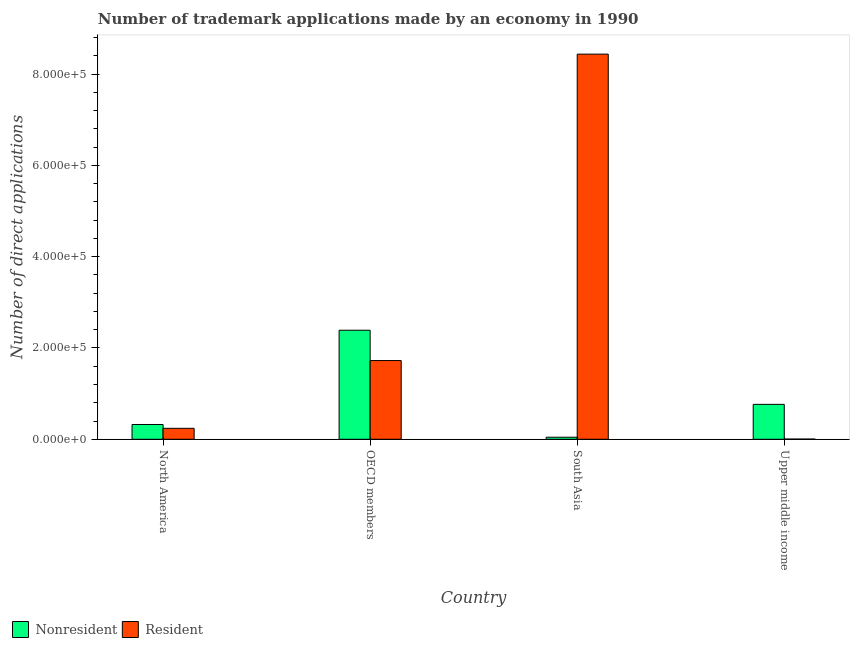How many different coloured bars are there?
Your answer should be compact. 2. How many groups of bars are there?
Your response must be concise. 4. Are the number of bars per tick equal to the number of legend labels?
Keep it short and to the point. Yes. What is the label of the 2nd group of bars from the left?
Offer a very short reply. OECD members. What is the number of trademark applications made by non residents in OECD members?
Offer a terse response. 2.39e+05. Across all countries, what is the maximum number of trademark applications made by non residents?
Provide a short and direct response. 2.39e+05. Across all countries, what is the minimum number of trademark applications made by residents?
Your response must be concise. 461. In which country was the number of trademark applications made by residents maximum?
Provide a succinct answer. South Asia. In which country was the number of trademark applications made by residents minimum?
Offer a very short reply. Upper middle income. What is the total number of trademark applications made by residents in the graph?
Keep it short and to the point. 1.04e+06. What is the difference between the number of trademark applications made by non residents in OECD members and that in Upper middle income?
Offer a terse response. 1.62e+05. What is the difference between the number of trademark applications made by residents in Upper middle income and the number of trademark applications made by non residents in South Asia?
Your answer should be compact. -4037. What is the average number of trademark applications made by non residents per country?
Provide a short and direct response. 8.81e+04. What is the difference between the number of trademark applications made by non residents and number of trademark applications made by residents in South Asia?
Give a very brief answer. -8.39e+05. What is the ratio of the number of trademark applications made by non residents in North America to that in South Asia?
Offer a very short reply. 7.2. What is the difference between the highest and the second highest number of trademark applications made by non residents?
Your response must be concise. 1.62e+05. What is the difference between the highest and the lowest number of trademark applications made by residents?
Offer a terse response. 8.43e+05. Is the sum of the number of trademark applications made by residents in North America and OECD members greater than the maximum number of trademark applications made by non residents across all countries?
Keep it short and to the point. No. What does the 1st bar from the left in Upper middle income represents?
Offer a terse response. Nonresident. What does the 2nd bar from the right in OECD members represents?
Offer a terse response. Nonresident. How many bars are there?
Your answer should be very brief. 8. How many countries are there in the graph?
Offer a terse response. 4. Does the graph contain any zero values?
Ensure brevity in your answer.  No. How are the legend labels stacked?
Provide a short and direct response. Horizontal. What is the title of the graph?
Ensure brevity in your answer.  Number of trademark applications made by an economy in 1990. What is the label or title of the Y-axis?
Your answer should be compact. Number of direct applications. What is the Number of direct applications in Nonresident in North America?
Your response must be concise. 3.24e+04. What is the Number of direct applications of Resident in North America?
Offer a very short reply. 2.40e+04. What is the Number of direct applications in Nonresident in OECD members?
Provide a short and direct response. 2.39e+05. What is the Number of direct applications in Resident in OECD members?
Your answer should be compact. 1.72e+05. What is the Number of direct applications of Nonresident in South Asia?
Give a very brief answer. 4498. What is the Number of direct applications in Resident in South Asia?
Keep it short and to the point. 8.44e+05. What is the Number of direct applications of Nonresident in Upper middle income?
Ensure brevity in your answer.  7.65e+04. What is the Number of direct applications in Resident in Upper middle income?
Offer a terse response. 461. Across all countries, what is the maximum Number of direct applications of Nonresident?
Offer a terse response. 2.39e+05. Across all countries, what is the maximum Number of direct applications in Resident?
Make the answer very short. 8.44e+05. Across all countries, what is the minimum Number of direct applications in Nonresident?
Your response must be concise. 4498. Across all countries, what is the minimum Number of direct applications in Resident?
Your answer should be compact. 461. What is the total Number of direct applications in Nonresident in the graph?
Make the answer very short. 3.52e+05. What is the total Number of direct applications in Resident in the graph?
Provide a short and direct response. 1.04e+06. What is the difference between the Number of direct applications in Nonresident in North America and that in OECD members?
Offer a terse response. -2.06e+05. What is the difference between the Number of direct applications in Resident in North America and that in OECD members?
Keep it short and to the point. -1.48e+05. What is the difference between the Number of direct applications in Nonresident in North America and that in South Asia?
Provide a succinct answer. 2.79e+04. What is the difference between the Number of direct applications of Resident in North America and that in South Asia?
Provide a succinct answer. -8.20e+05. What is the difference between the Number of direct applications of Nonresident in North America and that in Upper middle income?
Keep it short and to the point. -4.41e+04. What is the difference between the Number of direct applications in Resident in North America and that in Upper middle income?
Your answer should be very brief. 2.35e+04. What is the difference between the Number of direct applications in Nonresident in OECD members and that in South Asia?
Keep it short and to the point. 2.34e+05. What is the difference between the Number of direct applications of Resident in OECD members and that in South Asia?
Provide a succinct answer. -6.71e+05. What is the difference between the Number of direct applications in Nonresident in OECD members and that in Upper middle income?
Ensure brevity in your answer.  1.62e+05. What is the difference between the Number of direct applications of Resident in OECD members and that in Upper middle income?
Provide a short and direct response. 1.72e+05. What is the difference between the Number of direct applications of Nonresident in South Asia and that in Upper middle income?
Ensure brevity in your answer.  -7.20e+04. What is the difference between the Number of direct applications of Resident in South Asia and that in Upper middle income?
Ensure brevity in your answer.  8.43e+05. What is the difference between the Number of direct applications in Nonresident in North America and the Number of direct applications in Resident in OECD members?
Offer a terse response. -1.40e+05. What is the difference between the Number of direct applications in Nonresident in North America and the Number of direct applications in Resident in South Asia?
Offer a very short reply. -8.11e+05. What is the difference between the Number of direct applications in Nonresident in North America and the Number of direct applications in Resident in Upper middle income?
Provide a short and direct response. 3.19e+04. What is the difference between the Number of direct applications in Nonresident in OECD members and the Number of direct applications in Resident in South Asia?
Provide a short and direct response. -6.05e+05. What is the difference between the Number of direct applications of Nonresident in OECD members and the Number of direct applications of Resident in Upper middle income?
Make the answer very short. 2.38e+05. What is the difference between the Number of direct applications of Nonresident in South Asia and the Number of direct applications of Resident in Upper middle income?
Your answer should be compact. 4037. What is the average Number of direct applications in Nonresident per country?
Your answer should be compact. 8.81e+04. What is the average Number of direct applications in Resident per country?
Keep it short and to the point. 2.60e+05. What is the difference between the Number of direct applications of Nonresident and Number of direct applications of Resident in North America?
Provide a succinct answer. 8403. What is the difference between the Number of direct applications in Nonresident and Number of direct applications in Resident in OECD members?
Keep it short and to the point. 6.64e+04. What is the difference between the Number of direct applications in Nonresident and Number of direct applications in Resident in South Asia?
Make the answer very short. -8.39e+05. What is the difference between the Number of direct applications in Nonresident and Number of direct applications in Resident in Upper middle income?
Provide a short and direct response. 7.60e+04. What is the ratio of the Number of direct applications in Nonresident in North America to that in OECD members?
Give a very brief answer. 0.14. What is the ratio of the Number of direct applications of Resident in North America to that in OECD members?
Your answer should be compact. 0.14. What is the ratio of the Number of direct applications of Nonresident in North America to that in South Asia?
Keep it short and to the point. 7.2. What is the ratio of the Number of direct applications of Resident in North America to that in South Asia?
Provide a succinct answer. 0.03. What is the ratio of the Number of direct applications of Nonresident in North America to that in Upper middle income?
Offer a terse response. 0.42. What is the ratio of the Number of direct applications of Resident in North America to that in Upper middle income?
Make the answer very short. 52.02. What is the ratio of the Number of direct applications of Nonresident in OECD members to that in South Asia?
Offer a very short reply. 53.1. What is the ratio of the Number of direct applications of Resident in OECD members to that in South Asia?
Provide a succinct answer. 0.2. What is the ratio of the Number of direct applications in Nonresident in OECD members to that in Upper middle income?
Keep it short and to the point. 3.12. What is the ratio of the Number of direct applications in Resident in OECD members to that in Upper middle income?
Make the answer very short. 374.1. What is the ratio of the Number of direct applications in Nonresident in South Asia to that in Upper middle income?
Keep it short and to the point. 0.06. What is the ratio of the Number of direct applications of Resident in South Asia to that in Upper middle income?
Provide a succinct answer. 1830.3. What is the difference between the highest and the second highest Number of direct applications of Nonresident?
Make the answer very short. 1.62e+05. What is the difference between the highest and the second highest Number of direct applications of Resident?
Make the answer very short. 6.71e+05. What is the difference between the highest and the lowest Number of direct applications in Nonresident?
Provide a succinct answer. 2.34e+05. What is the difference between the highest and the lowest Number of direct applications of Resident?
Keep it short and to the point. 8.43e+05. 